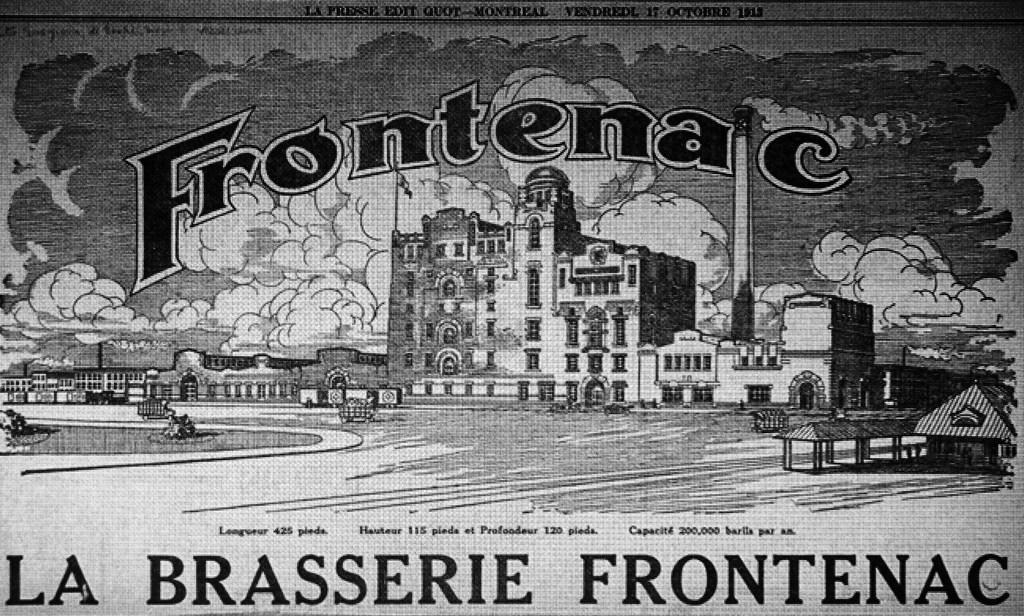How would you summarize this image in a sentence or two? It is a black and white image, in there is a building and there are clouds. 